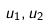Convert formula to latex. <formula><loc_0><loc_0><loc_500><loc_500>u _ { 1 } , u _ { 2 }</formula> 